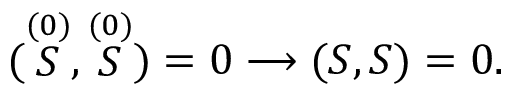<formula> <loc_0><loc_0><loc_500><loc_500>( \stackrel { ( 0 ) } { S } , \stackrel { ( 0 ) } { S } ) = 0 \longrightarrow ( S , S ) = 0 .</formula> 